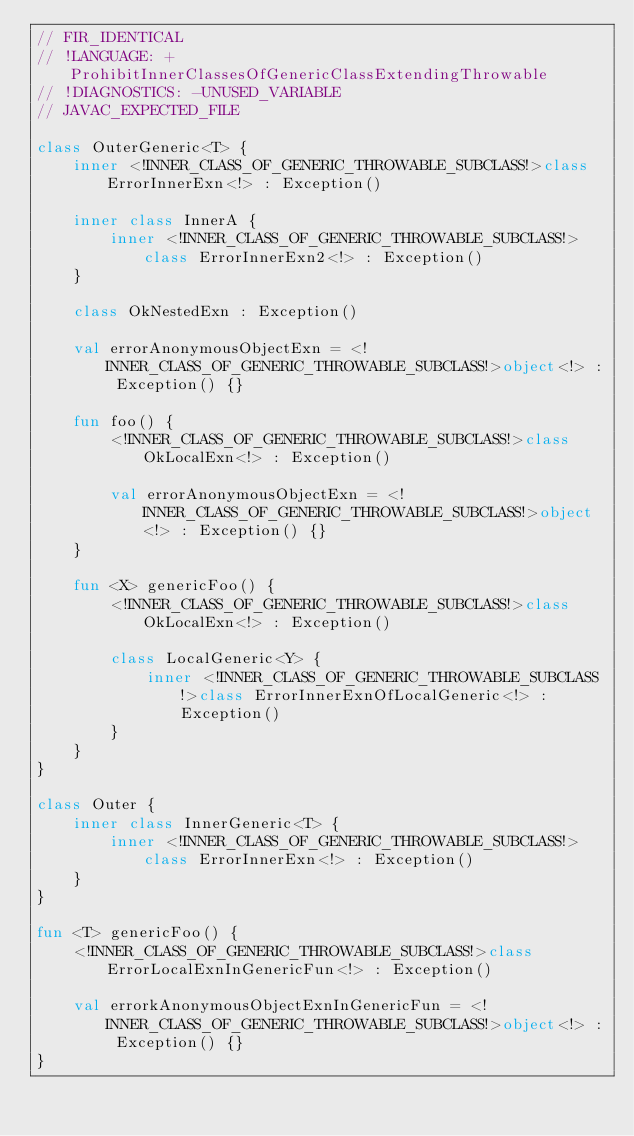<code> <loc_0><loc_0><loc_500><loc_500><_Kotlin_>// FIR_IDENTICAL
// !LANGUAGE: +ProhibitInnerClassesOfGenericClassExtendingThrowable
// !DIAGNOSTICS: -UNUSED_VARIABLE
// JAVAC_EXPECTED_FILE

class OuterGeneric<T> {
    inner <!INNER_CLASS_OF_GENERIC_THROWABLE_SUBCLASS!>class ErrorInnerExn<!> : Exception()

    inner class InnerA {
        inner <!INNER_CLASS_OF_GENERIC_THROWABLE_SUBCLASS!>class ErrorInnerExn2<!> : Exception()
    }

    class OkNestedExn : Exception()

    val errorAnonymousObjectExn = <!INNER_CLASS_OF_GENERIC_THROWABLE_SUBCLASS!>object<!> : Exception() {}

    fun foo() {
        <!INNER_CLASS_OF_GENERIC_THROWABLE_SUBCLASS!>class OkLocalExn<!> : Exception()

        val errorAnonymousObjectExn = <!INNER_CLASS_OF_GENERIC_THROWABLE_SUBCLASS!>object<!> : Exception() {}
    }

    fun <X> genericFoo() {
        <!INNER_CLASS_OF_GENERIC_THROWABLE_SUBCLASS!>class OkLocalExn<!> : Exception()

        class LocalGeneric<Y> {
            inner <!INNER_CLASS_OF_GENERIC_THROWABLE_SUBCLASS!>class ErrorInnerExnOfLocalGeneric<!> : Exception()
        }
    }
}

class Outer {
    inner class InnerGeneric<T> {
        inner <!INNER_CLASS_OF_GENERIC_THROWABLE_SUBCLASS!>class ErrorInnerExn<!> : Exception()
    }
}

fun <T> genericFoo() {
    <!INNER_CLASS_OF_GENERIC_THROWABLE_SUBCLASS!>class ErrorLocalExnInGenericFun<!> : Exception()

    val errorkAnonymousObjectExnInGenericFun = <!INNER_CLASS_OF_GENERIC_THROWABLE_SUBCLASS!>object<!> : Exception() {}
}
</code> 